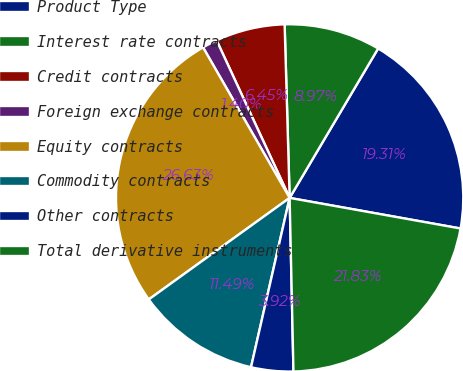<chart> <loc_0><loc_0><loc_500><loc_500><pie_chart><fcel>Product Type<fcel>Interest rate contracts<fcel>Credit contracts<fcel>Foreign exchange contracts<fcel>Equity contracts<fcel>Commodity contracts<fcel>Other contracts<fcel>Total derivative instruments<nl><fcel>19.31%<fcel>8.97%<fcel>6.45%<fcel>1.4%<fcel>26.63%<fcel>11.49%<fcel>3.92%<fcel>21.83%<nl></chart> 